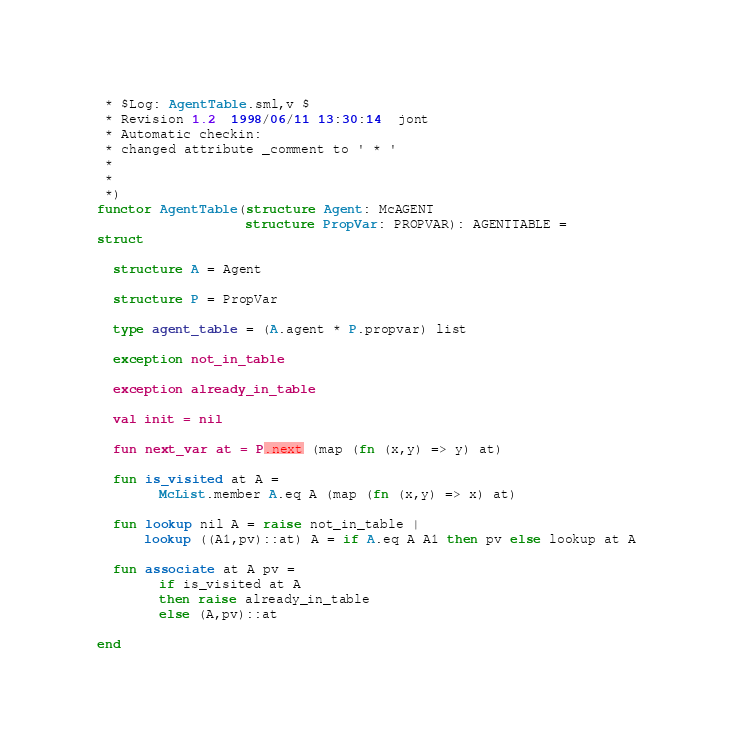<code> <loc_0><loc_0><loc_500><loc_500><_SML_> * $Log: AgentTable.sml,v $
 * Revision 1.2  1998/06/11 13:30:14  jont
 * Automatic checkin:
 * changed attribute _comment to ' * '
 *
 *
 *)
functor AgentTable(structure Agent: McAGENT
                   structure PropVar: PROPVAR): AGENTTABLE =
struct

  structure A = Agent

  structure P = PropVar

  type agent_table = (A.agent * P.propvar) list

  exception not_in_table

  exception already_in_table

  val init = nil

  fun next_var at = P.next (map (fn (x,y) => y) at)
   
  fun is_visited at A =
        McList.member A.eq A (map (fn (x,y) => x) at)

  fun lookup nil A = raise not_in_table |
      lookup ((A1,pv)::at) A = if A.eq A A1 then pv else lookup at A

  fun associate at A pv =
        if is_visited at A
        then raise already_in_table
        else (A,pv)::at

end
</code> 